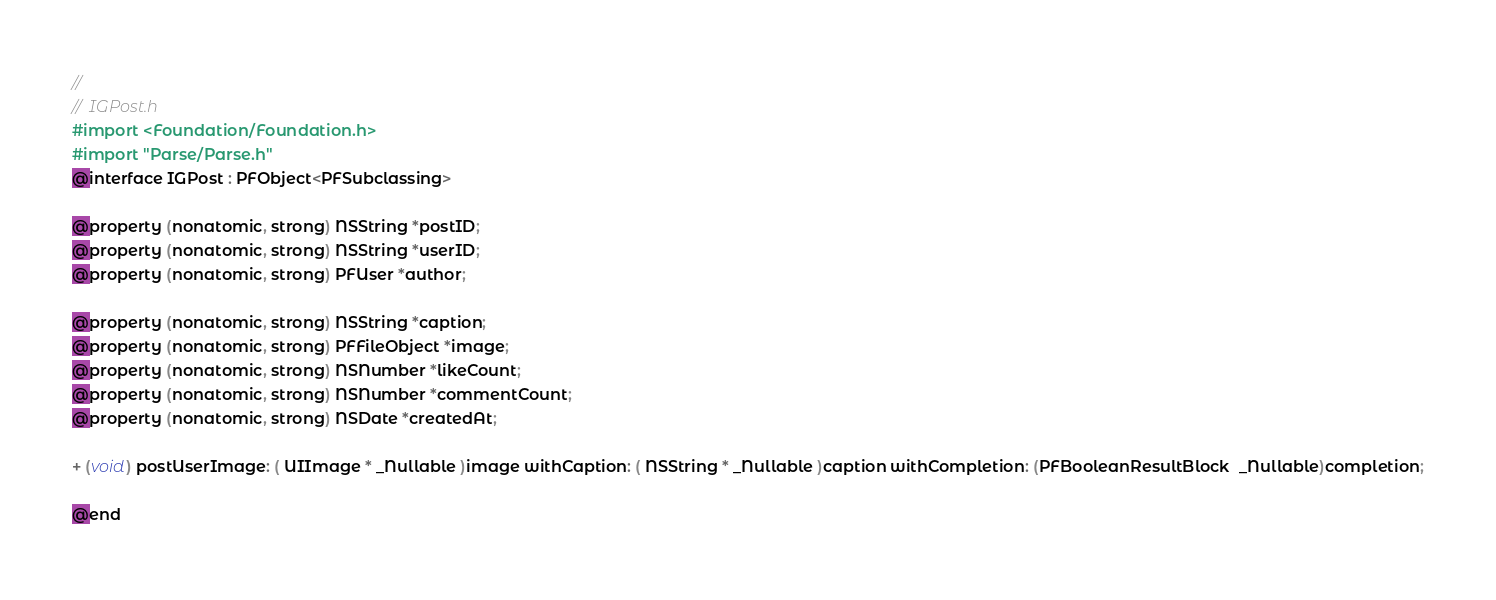Convert code to text. <code><loc_0><loc_0><loc_500><loc_500><_C_>//
//  IGPost.h
#import <Foundation/Foundation.h>
#import "Parse/Parse.h"
@interface IGPost : PFObject<PFSubclassing>

@property (nonatomic, strong) NSString *postID;
@property (nonatomic, strong) NSString *userID;
@property (nonatomic, strong) PFUser *author;

@property (nonatomic, strong) NSString *caption;
@property (nonatomic, strong) PFFileObject *image;
@property (nonatomic, strong) NSNumber *likeCount;
@property (nonatomic, strong) NSNumber *commentCount;
@property (nonatomic, strong) NSDate *createdAt;

+ (void) postUserImage: ( UIImage * _Nullable )image withCaption: ( NSString * _Nullable )caption withCompletion: (PFBooleanResultBlock  _Nullable)completion;

@end
</code> 